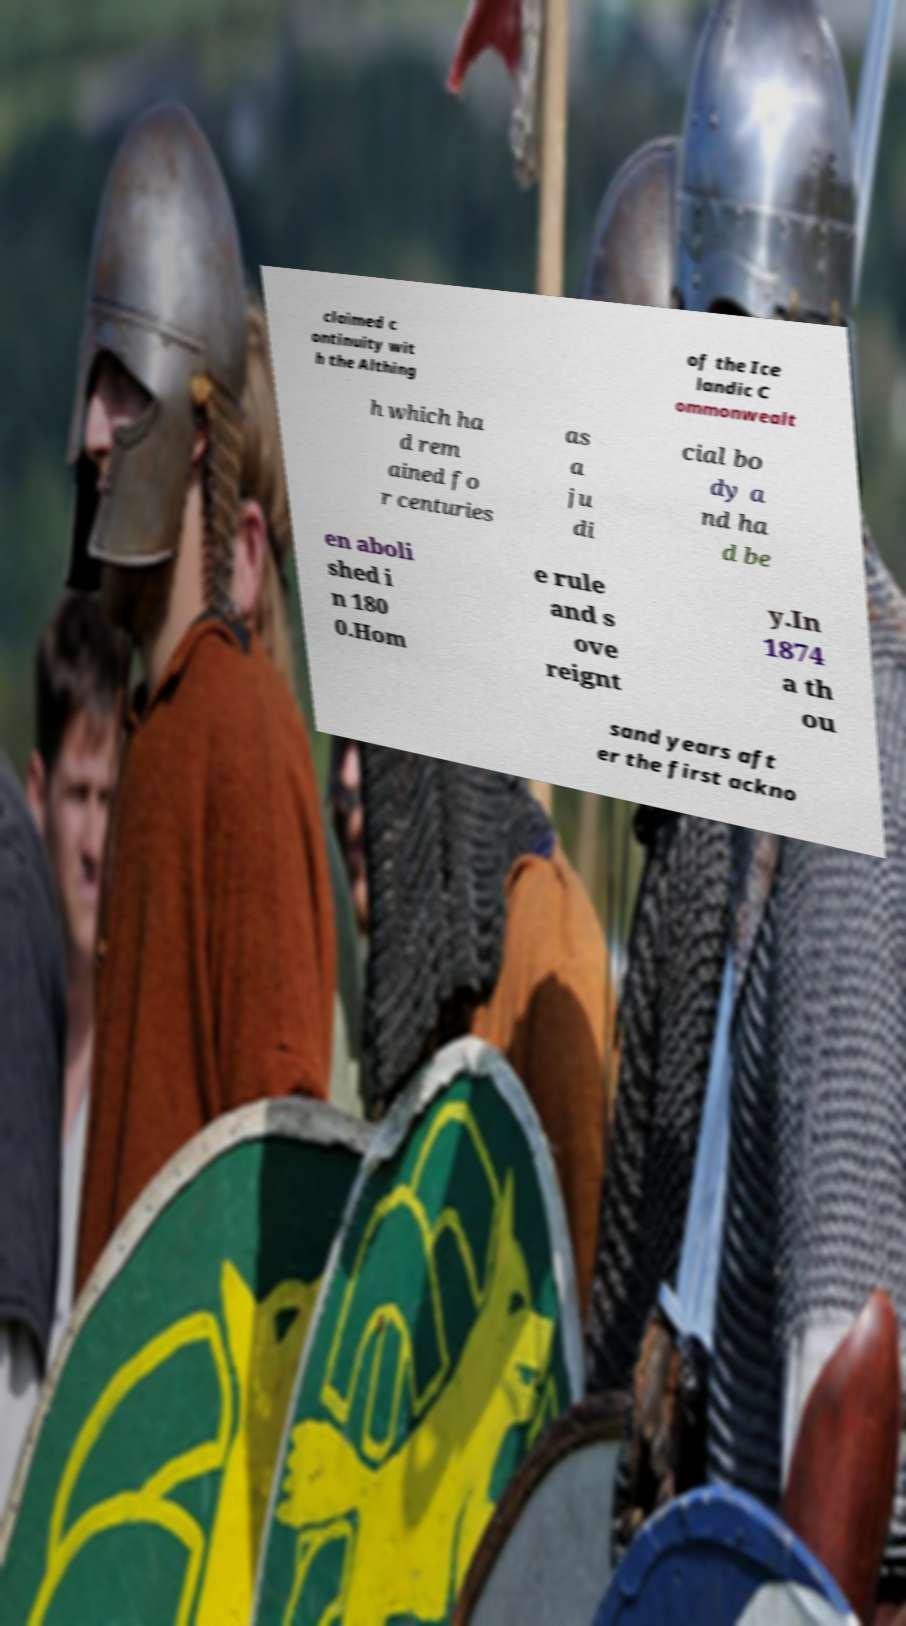Please read and relay the text visible in this image. What does it say? claimed c ontinuity wit h the Althing of the Ice landic C ommonwealt h which ha d rem ained fo r centuries as a ju di cial bo dy a nd ha d be en aboli shed i n 180 0.Hom e rule and s ove reignt y.In 1874 a th ou sand years aft er the first ackno 